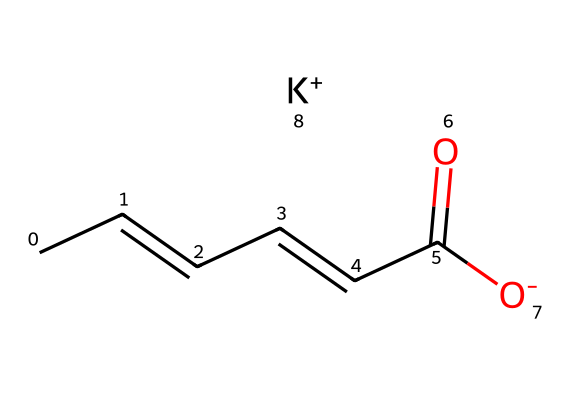What is the name of this chemical? The SMILES representation indicates that the chemical is potassium sorbate. The structure features a long chain and a carboxylate group with a potassium ion, which matches the known structure of potassium sorbate used as a food preservative.
Answer: potassium sorbate How many unsaturated bonds are present in this chemical? By analyzing the structure, we see that there are three carbon-carbon double bonds represented in the SMILES notation (C/C=C/C=C/), indicating unsaturation.
Answer: three What is the main functional group in potassium sorbate? The SMILES reveals a carboxylate group (C(=O)[O-]), which is characteristic of carboxylic acids and their salts. This functional group plays a crucial role in the preservative properties of the compound.
Answer: carboxylate How many carbon atoms are in potassium sorbate? The structure provided in the SMILES representation shows a total of six carbon atoms in the chain and the carboxylate part, which can be counted directly from the notation.
Answer: six What charge does the potassium ion carry in potassium sorbate? The potassium atom is indicated with [K+] in the SMILES structure, which denotes that the potassium ion carries a positive charge. This is common in salts derived from acids and contributes to the overall properties of the preservative.
Answer: positive What molecular property allows potassium sorbate to function as a preservative? The presence of the carboxylate group (C(=O)[O-]) and the unsaturation in the carbon chain help in inhibiting microbial growth by interfering with cellular mechanisms, making it effective as a preservative.
Answer: antimicrobial activity 